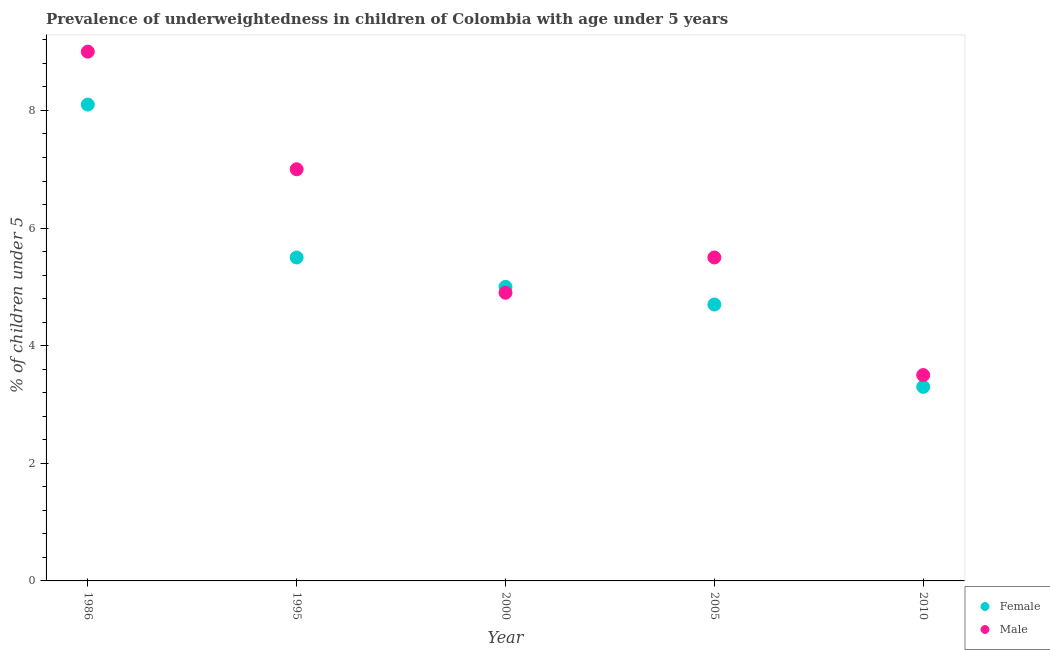Is the number of dotlines equal to the number of legend labels?
Your answer should be compact. Yes. What is the percentage of underweighted female children in 2010?
Your response must be concise. 3.3. Across all years, what is the minimum percentage of underweighted female children?
Make the answer very short. 3.3. In which year was the percentage of underweighted male children minimum?
Provide a short and direct response. 2010. What is the total percentage of underweighted male children in the graph?
Your response must be concise. 29.9. What is the difference between the percentage of underweighted female children in 1995 and that in 2005?
Keep it short and to the point. 0.8. What is the difference between the percentage of underweighted female children in 2010 and the percentage of underweighted male children in 2000?
Your answer should be very brief. -1.6. What is the average percentage of underweighted female children per year?
Keep it short and to the point. 5.32. In the year 2010, what is the difference between the percentage of underweighted male children and percentage of underweighted female children?
Keep it short and to the point. 0.2. In how many years, is the percentage of underweighted female children greater than 0.4 %?
Your answer should be very brief. 5. What is the ratio of the percentage of underweighted female children in 2000 to that in 2005?
Provide a short and direct response. 1.06. What is the difference between the highest and the second highest percentage of underweighted female children?
Your answer should be compact. 2.6. Is the sum of the percentage of underweighted male children in 2005 and 2010 greater than the maximum percentage of underweighted female children across all years?
Provide a short and direct response. Yes. Is the percentage of underweighted female children strictly greater than the percentage of underweighted male children over the years?
Offer a very short reply. No. Is the percentage of underweighted male children strictly less than the percentage of underweighted female children over the years?
Provide a succinct answer. No. How many dotlines are there?
Your answer should be compact. 2. How many years are there in the graph?
Give a very brief answer. 5. What is the difference between two consecutive major ticks on the Y-axis?
Offer a terse response. 2. Are the values on the major ticks of Y-axis written in scientific E-notation?
Give a very brief answer. No. Does the graph contain grids?
Your answer should be very brief. No. What is the title of the graph?
Give a very brief answer. Prevalence of underweightedness in children of Colombia with age under 5 years. Does "Residents" appear as one of the legend labels in the graph?
Give a very brief answer. No. What is the label or title of the Y-axis?
Provide a succinct answer.  % of children under 5. What is the  % of children under 5 of Female in 1986?
Your answer should be compact. 8.1. What is the  % of children under 5 of Female in 2000?
Your answer should be compact. 5. What is the  % of children under 5 of Male in 2000?
Keep it short and to the point. 4.9. What is the  % of children under 5 in Female in 2005?
Offer a very short reply. 4.7. What is the  % of children under 5 in Female in 2010?
Provide a short and direct response. 3.3. Across all years, what is the maximum  % of children under 5 in Female?
Offer a very short reply. 8.1. Across all years, what is the maximum  % of children under 5 in Male?
Your response must be concise. 9. Across all years, what is the minimum  % of children under 5 in Female?
Your response must be concise. 3.3. What is the total  % of children under 5 of Female in the graph?
Give a very brief answer. 26.6. What is the total  % of children under 5 in Male in the graph?
Provide a short and direct response. 29.9. What is the difference between the  % of children under 5 in Female in 1986 and that in 1995?
Provide a succinct answer. 2.6. What is the difference between the  % of children under 5 in Male in 1986 and that in 1995?
Offer a very short reply. 2. What is the difference between the  % of children under 5 of Female in 1986 and that in 2000?
Offer a terse response. 3.1. What is the difference between the  % of children under 5 of Male in 1986 and that in 2000?
Provide a short and direct response. 4.1. What is the difference between the  % of children under 5 in Female in 1986 and that in 2005?
Give a very brief answer. 3.4. What is the difference between the  % of children under 5 in Male in 1986 and that in 2005?
Offer a terse response. 3.5. What is the difference between the  % of children under 5 in Female in 1986 and that in 2010?
Offer a terse response. 4.8. What is the difference between the  % of children under 5 of Male in 1986 and that in 2010?
Your answer should be very brief. 5.5. What is the difference between the  % of children under 5 of Female in 1995 and that in 2000?
Your response must be concise. 0.5. What is the difference between the  % of children under 5 in Female in 1995 and that in 2005?
Your answer should be compact. 0.8. What is the difference between the  % of children under 5 of Female in 2000 and that in 2005?
Ensure brevity in your answer.  0.3. What is the difference between the  % of children under 5 in Female in 2000 and that in 2010?
Your answer should be very brief. 1.7. What is the difference between the  % of children under 5 in Female in 2005 and that in 2010?
Offer a very short reply. 1.4. What is the difference between the  % of children under 5 of Female in 1986 and the  % of children under 5 of Male in 2000?
Offer a terse response. 3.2. What is the difference between the  % of children under 5 in Female in 1986 and the  % of children under 5 in Male in 2005?
Offer a very short reply. 2.6. What is the difference between the  % of children under 5 in Female in 1986 and the  % of children under 5 in Male in 2010?
Ensure brevity in your answer.  4.6. What is the difference between the  % of children under 5 in Female in 1995 and the  % of children under 5 in Male in 2010?
Your response must be concise. 2. What is the difference between the  % of children under 5 of Female in 2000 and the  % of children under 5 of Male in 2010?
Your answer should be very brief. 1.5. What is the difference between the  % of children under 5 of Female in 2005 and the  % of children under 5 of Male in 2010?
Your response must be concise. 1.2. What is the average  % of children under 5 in Female per year?
Give a very brief answer. 5.32. What is the average  % of children under 5 of Male per year?
Keep it short and to the point. 5.98. In the year 1986, what is the difference between the  % of children under 5 in Female and  % of children under 5 in Male?
Keep it short and to the point. -0.9. What is the ratio of the  % of children under 5 of Female in 1986 to that in 1995?
Your response must be concise. 1.47. What is the ratio of the  % of children under 5 of Male in 1986 to that in 1995?
Provide a short and direct response. 1.29. What is the ratio of the  % of children under 5 of Female in 1986 to that in 2000?
Your response must be concise. 1.62. What is the ratio of the  % of children under 5 in Male in 1986 to that in 2000?
Keep it short and to the point. 1.84. What is the ratio of the  % of children under 5 of Female in 1986 to that in 2005?
Your answer should be very brief. 1.72. What is the ratio of the  % of children under 5 in Male in 1986 to that in 2005?
Keep it short and to the point. 1.64. What is the ratio of the  % of children under 5 of Female in 1986 to that in 2010?
Your response must be concise. 2.45. What is the ratio of the  % of children under 5 of Male in 1986 to that in 2010?
Your response must be concise. 2.57. What is the ratio of the  % of children under 5 in Male in 1995 to that in 2000?
Your answer should be compact. 1.43. What is the ratio of the  % of children under 5 of Female in 1995 to that in 2005?
Your response must be concise. 1.17. What is the ratio of the  % of children under 5 of Male in 1995 to that in 2005?
Provide a short and direct response. 1.27. What is the ratio of the  % of children under 5 of Female in 1995 to that in 2010?
Keep it short and to the point. 1.67. What is the ratio of the  % of children under 5 of Female in 2000 to that in 2005?
Your answer should be very brief. 1.06. What is the ratio of the  % of children under 5 of Male in 2000 to that in 2005?
Keep it short and to the point. 0.89. What is the ratio of the  % of children under 5 of Female in 2000 to that in 2010?
Make the answer very short. 1.52. What is the ratio of the  % of children under 5 in Female in 2005 to that in 2010?
Make the answer very short. 1.42. What is the ratio of the  % of children under 5 of Male in 2005 to that in 2010?
Provide a succinct answer. 1.57. What is the difference between the highest and the second highest  % of children under 5 of Female?
Keep it short and to the point. 2.6. What is the difference between the highest and the lowest  % of children under 5 of Female?
Your response must be concise. 4.8. What is the difference between the highest and the lowest  % of children under 5 in Male?
Ensure brevity in your answer.  5.5. 